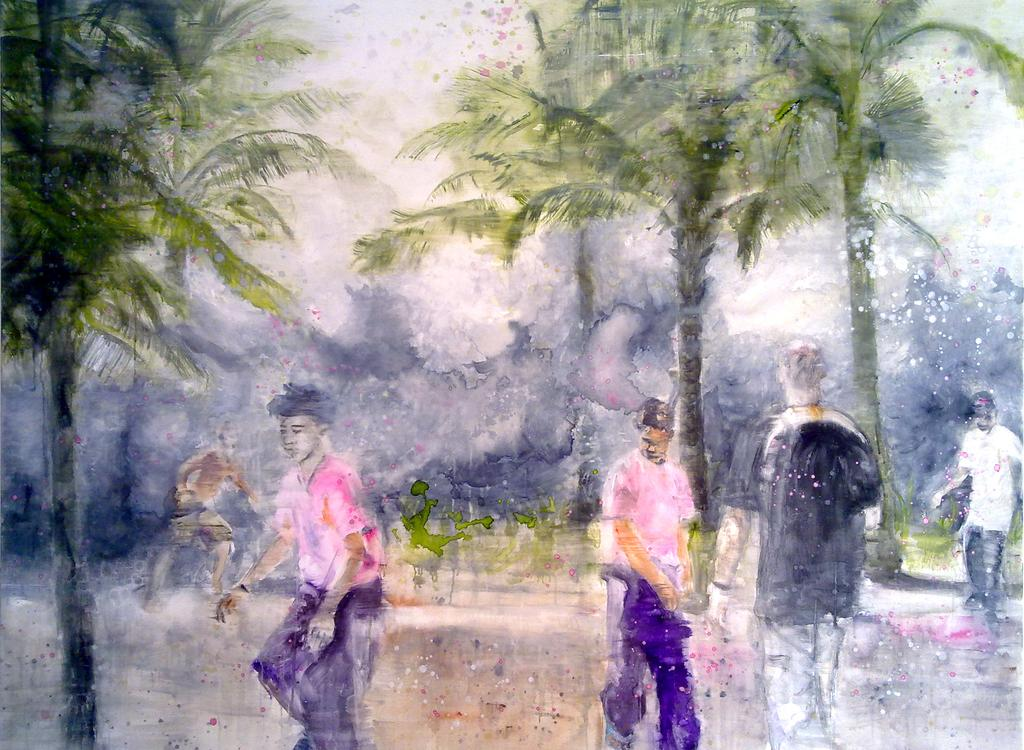What type of artwork is depicted in the image? The image is a painting. What can be seen in the painting? There are persons in different color dresses, trees, plants on the ground, and clouds in the sky in the background of the painting. How many different colors of dresses can be seen on the persons in the painting? The number of different colors of dresses cannot be determined from the provided facts. What is the setting of the painting? The painting features a landscape with trees, plants, and clouds in the sky. Can you hear an alarm sounding in the painting? There is no alarm present in the painting, as it is a visual medium and does not contain audible elements. 